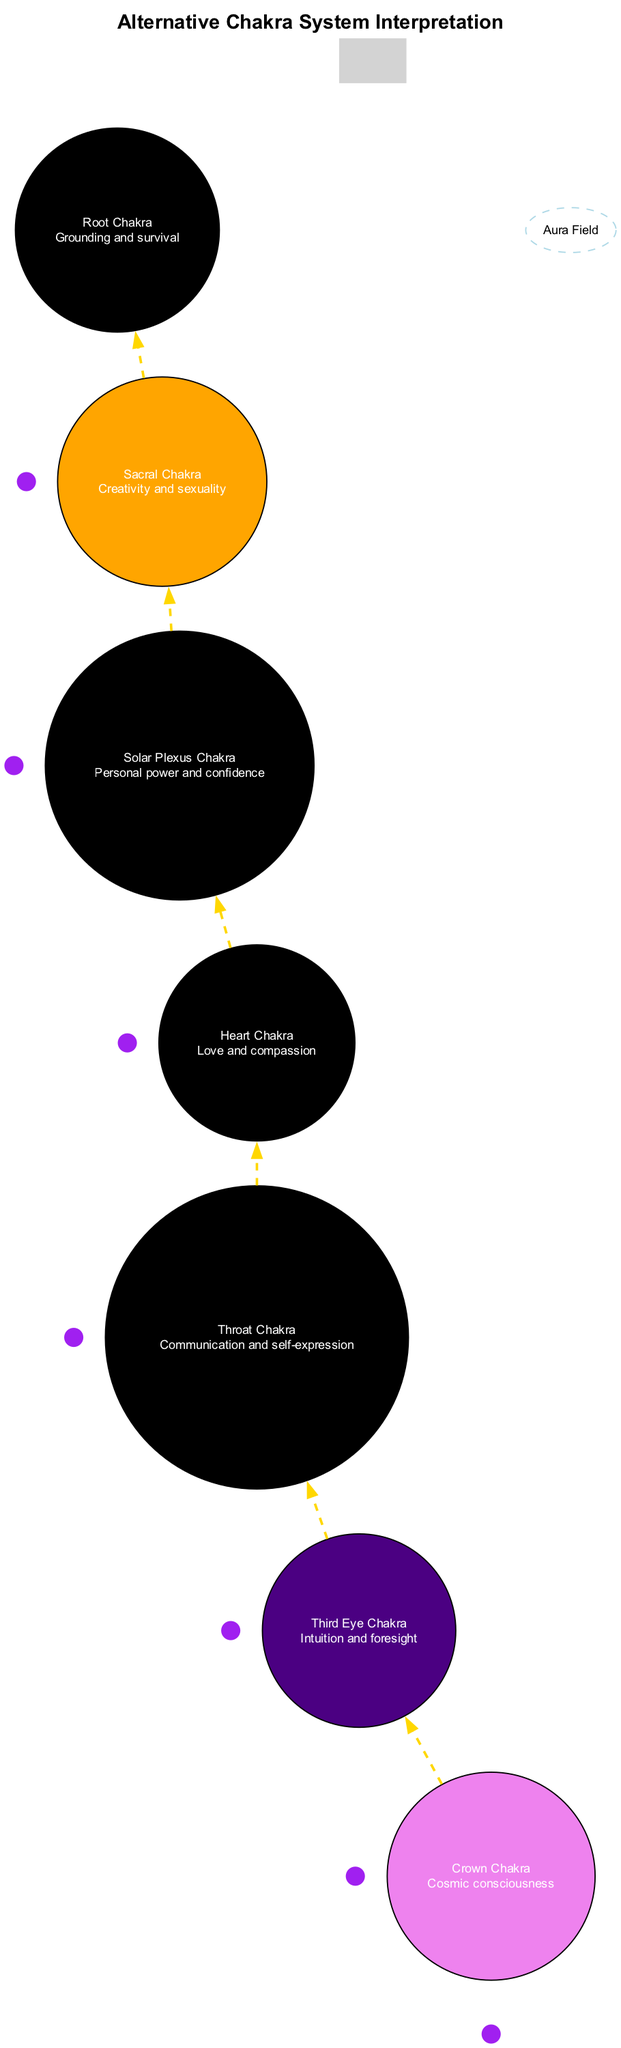What color is the Heart Chakra? The Heart Chakra is represented in the diagram with the color Emerald Green. This can be found in the listed chakra details.
Answer: Emerald Green Where is the Third Eye Chakra located? The Third Eye Chakra is located between the eyebrows as specified in the chakra information within the diagram.
Answer: Between eyebrows How many chakras are depicted in the diagram? There are seven chakras shown in the diagram, as indicated in the chakra list.
Answer: Seven What energy is associated with the Solar Plexus Chakra? The Solar Plexus Chakra's associated energy is personal power and confidence, noted in the chakra descriptions.
Answer: Personal power and confidence What type of symbols surround each chakra? The diagram indicates that psychic symbols are around each chakra, which is specifically listed in the additional elements.
Answer: Psychic symbols Which chakra is positioned at the base of the spine? The chakra at the base of the spine is the Root Chakra, as outlined in the chakra details.
Answer: Root Chakra What is the energy flow line color between chakras? The color of the energy flow lines connecting the chakras is gold, as described in the diagram's edge attributes.
Answer: Gold What does the aura field represent in the diagram? The aura field represents the surrounding energy field, which is detailed in the additional elements of the diagram.
Answer: Surrounding energy field 